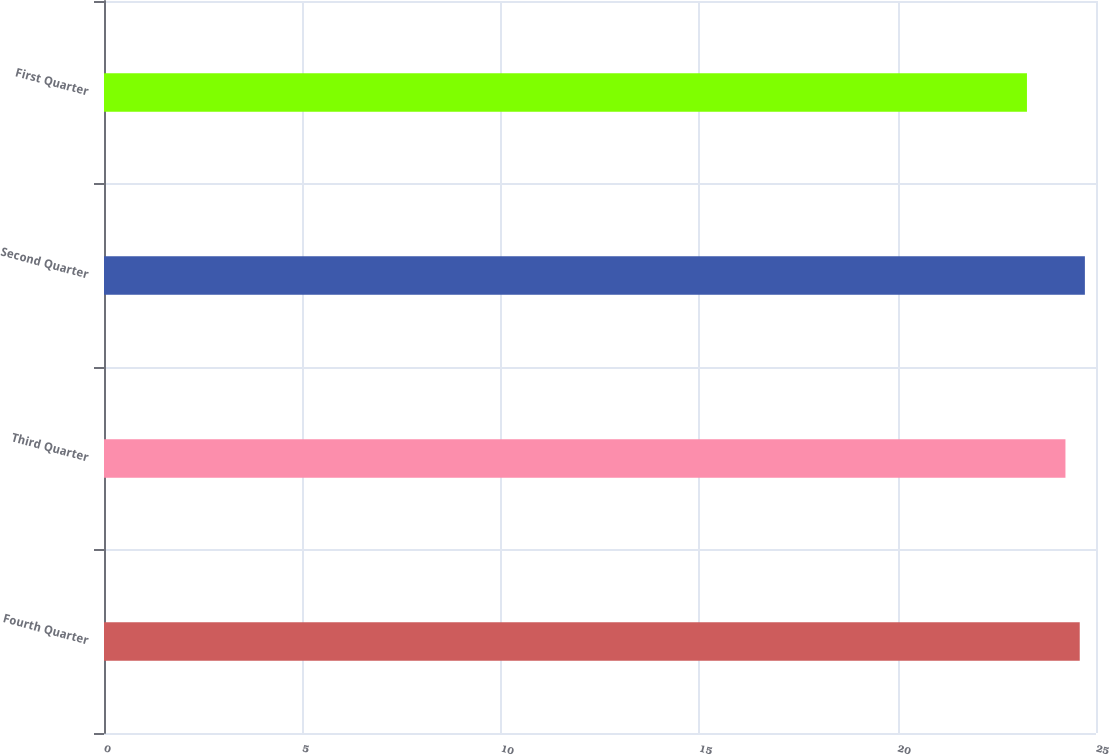<chart> <loc_0><loc_0><loc_500><loc_500><bar_chart><fcel>Fourth Quarter<fcel>Third Quarter<fcel>Second Quarter<fcel>First Quarter<nl><fcel>24.59<fcel>24.23<fcel>24.72<fcel>23.26<nl></chart> 